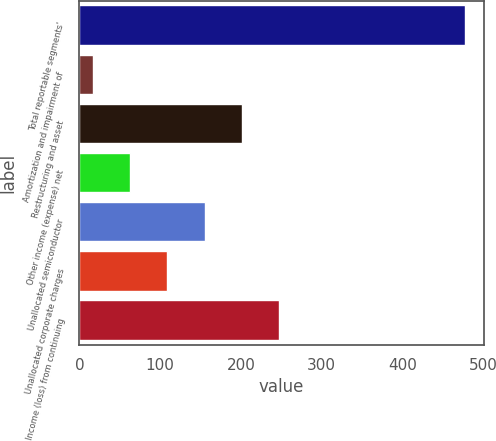Convert chart. <chart><loc_0><loc_0><loc_500><loc_500><bar_chart><fcel>Total reportable segments'<fcel>Amortization and impairment of<fcel>Restructuring and asset<fcel>Other income (expense) net<fcel>Unallocated semiconductor<fcel>Unallocated corporate charges<fcel>Income (loss) from continuing<nl><fcel>477<fcel>17<fcel>201<fcel>63<fcel>155<fcel>109<fcel>247<nl></chart> 